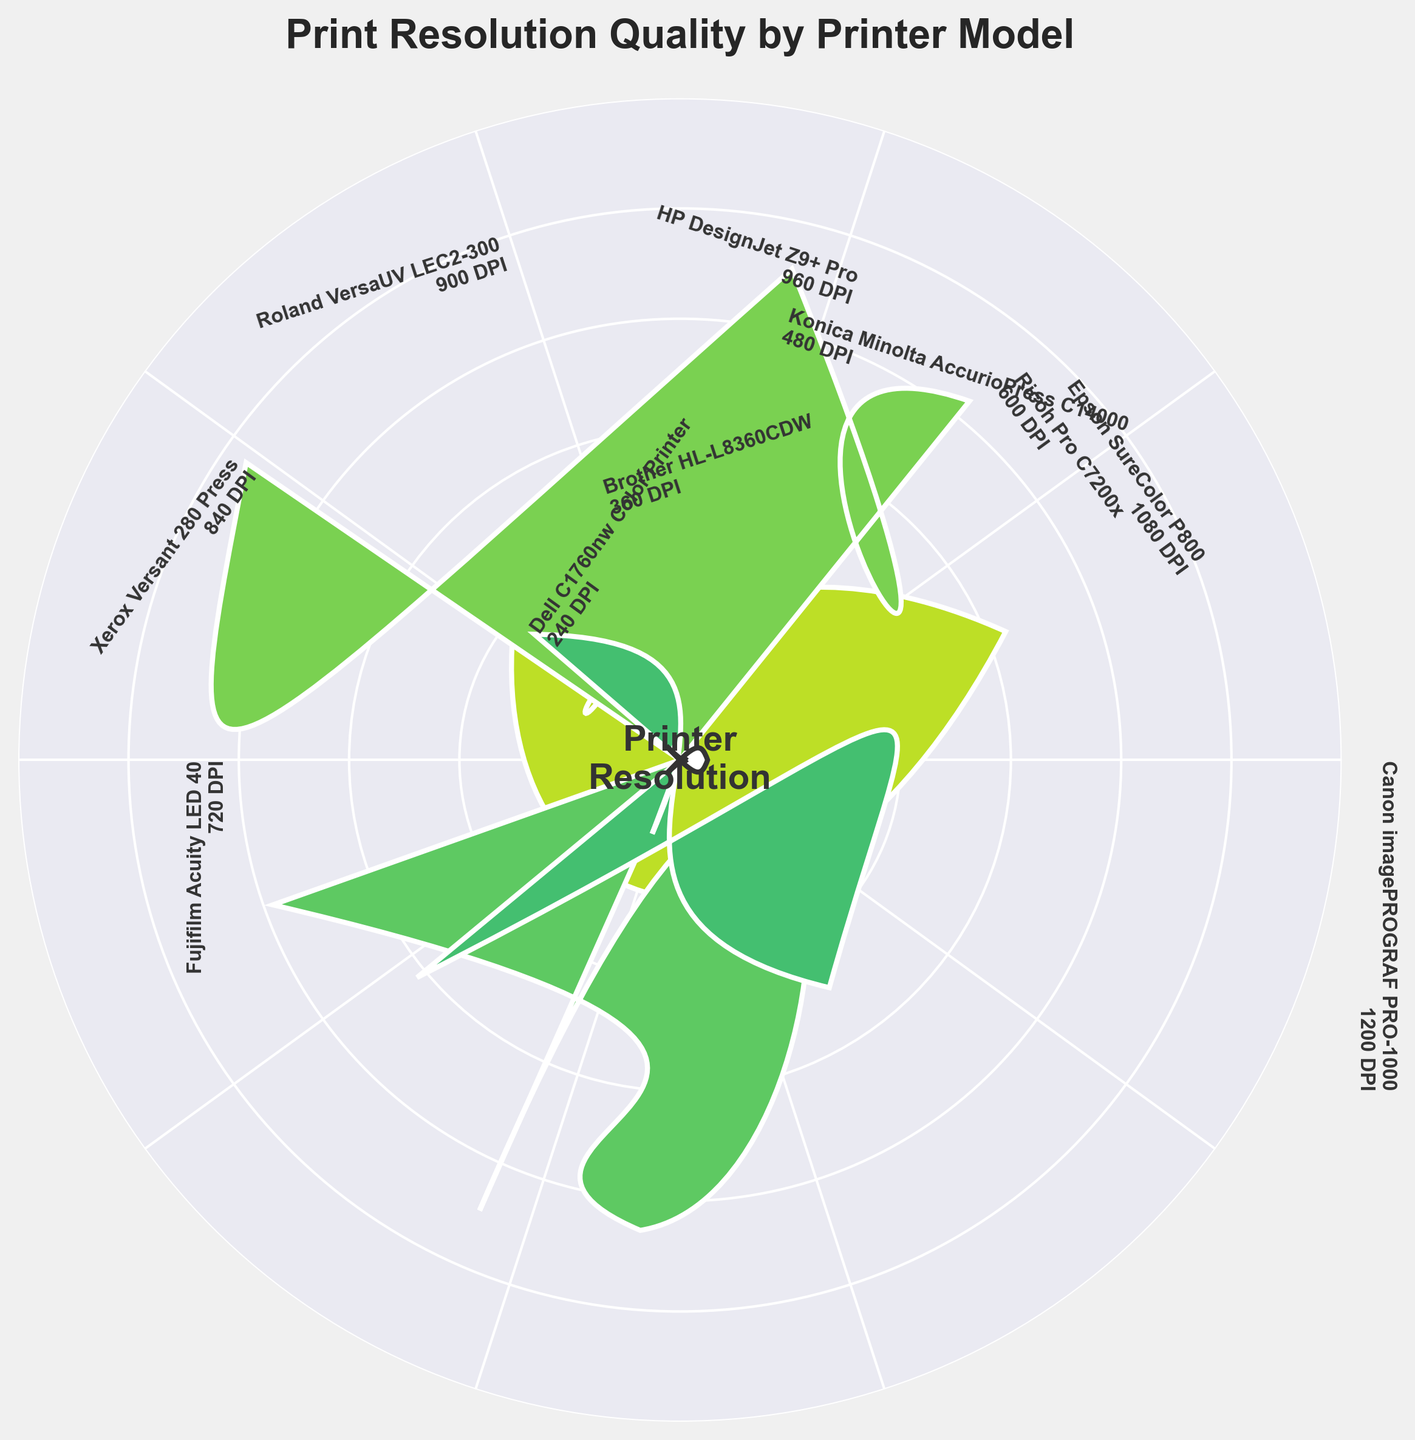what's the maximum print resolution displayed in the chart? The chart shows the print resolutions for various printer models, and the highest resolution displayed is 1200 DPI for Canon imagePROGRAF PRO-1000.
Answer: 1200 DPI How many printer models are displayed in the chart? The chart presents data for 10 different printer models.
Answer: 10 Which printer model has the lowest print resolution? The chart shows that Dell C1760nw Color Printer has the lowest print resolution of 240 DPI.
Answer: Dell C1760nw Color Printer Which printer models have a print resolution greater than 800 DPI but less than 1000 DPI? Models with print resolutions in this range include HP DesignJet Z9+ Pro (960 DPI) and Roland VersaUV LEC2-300 (900 DPI).
Answer: HP DesignJet Z9+ Pro and Roland VersaUV LEC2-300 What's the average print resolution of the top 3 printers? The top 3 printers by resolution are Canon imagePROGRAF PRO-1000 (1200 DPI), Epson SureColor P800 (1080 DPI), and HP DesignJet Z9+ Pro (960 DPI). The sum of these DPIs is 1200 + 1080 + 960 = 3240, and the average is 3240/3 = 1080 DPI.
Answer: 1080 DPI How much higher is the maximum print resolution than the minimum print resolution shown? The highest resolution is 1200 DPI and the lowest is 240 DPI, so the difference is 1200 - 240 = 960 DPI.
Answer: 960 DPI Which printer model is closest to achieving a print resolution of 500 DPI? The chart shows that Konica Minolta AccurioPress C14000 has a print resolution of 480 DPI, which is closest to 500 DPI.
Answer: Konica Minolta AccurioPress C14000 What is the median print resolution of all the printers displayed? The ordered print resolutions are: 240, 360, 480, 600, 720, 840, 900, 960, 1080, 1200. The median is the average of the 5th and 6th values: (720 + 840) / 2 = 780 DPI.
Answer: 780 DPI What is the color indicating the highest print resolution in the chart? The color representing the Canon imagePROGRAF PRO-1000 with the maximum print resolution of 1200 DPI is the brightest or the most intense color in the viridis color map.
Answer: Brightest color 